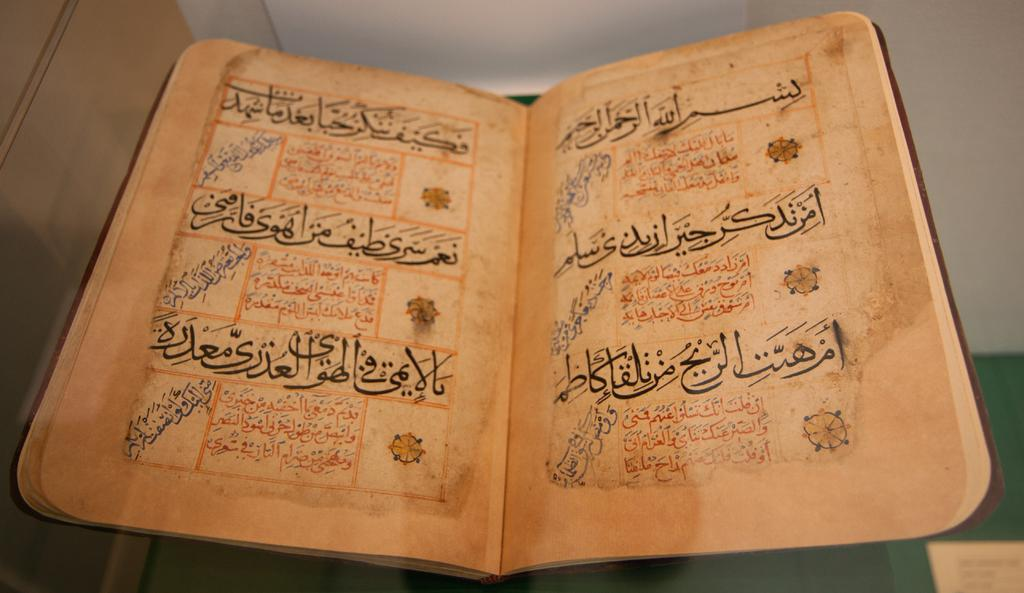<image>
Summarize the visual content of the image. A book is open with text all in Arabic. 